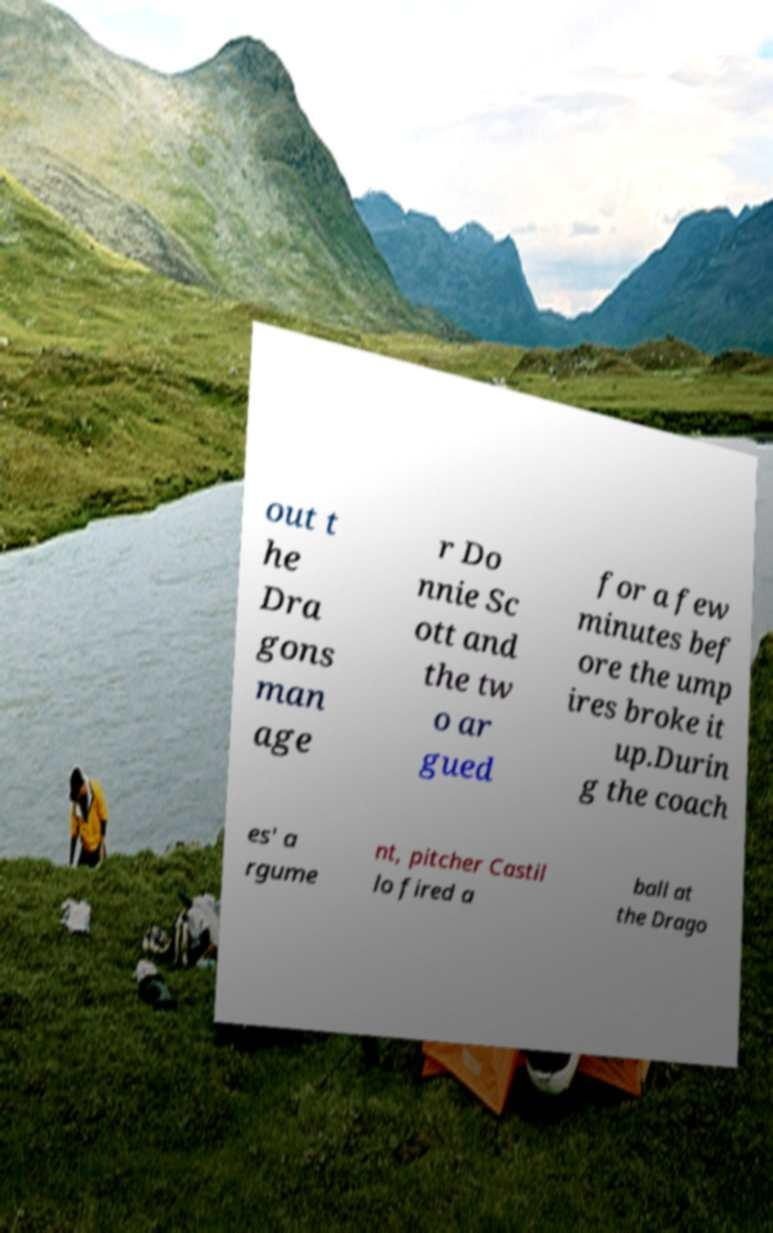Could you extract and type out the text from this image? out t he Dra gons man age r Do nnie Sc ott and the tw o ar gued for a few minutes bef ore the ump ires broke it up.Durin g the coach es' a rgume nt, pitcher Castil lo fired a ball at the Drago 